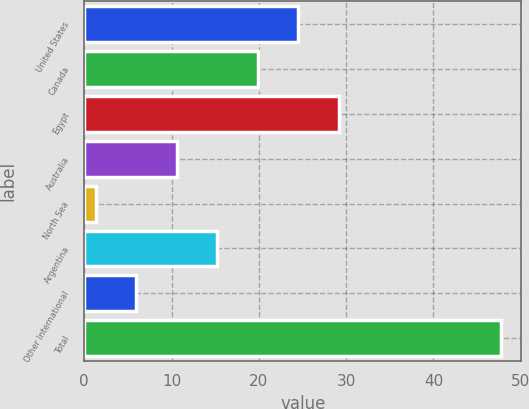Convert chart to OTSL. <chart><loc_0><loc_0><loc_500><loc_500><bar_chart><fcel>United States<fcel>Canada<fcel>Egypt<fcel>Australia<fcel>North Sea<fcel>Argentina<fcel>Other International<fcel>Total<nl><fcel>24.5<fcel>19.86<fcel>29.14<fcel>10.58<fcel>1.3<fcel>15.22<fcel>5.94<fcel>47.7<nl></chart> 